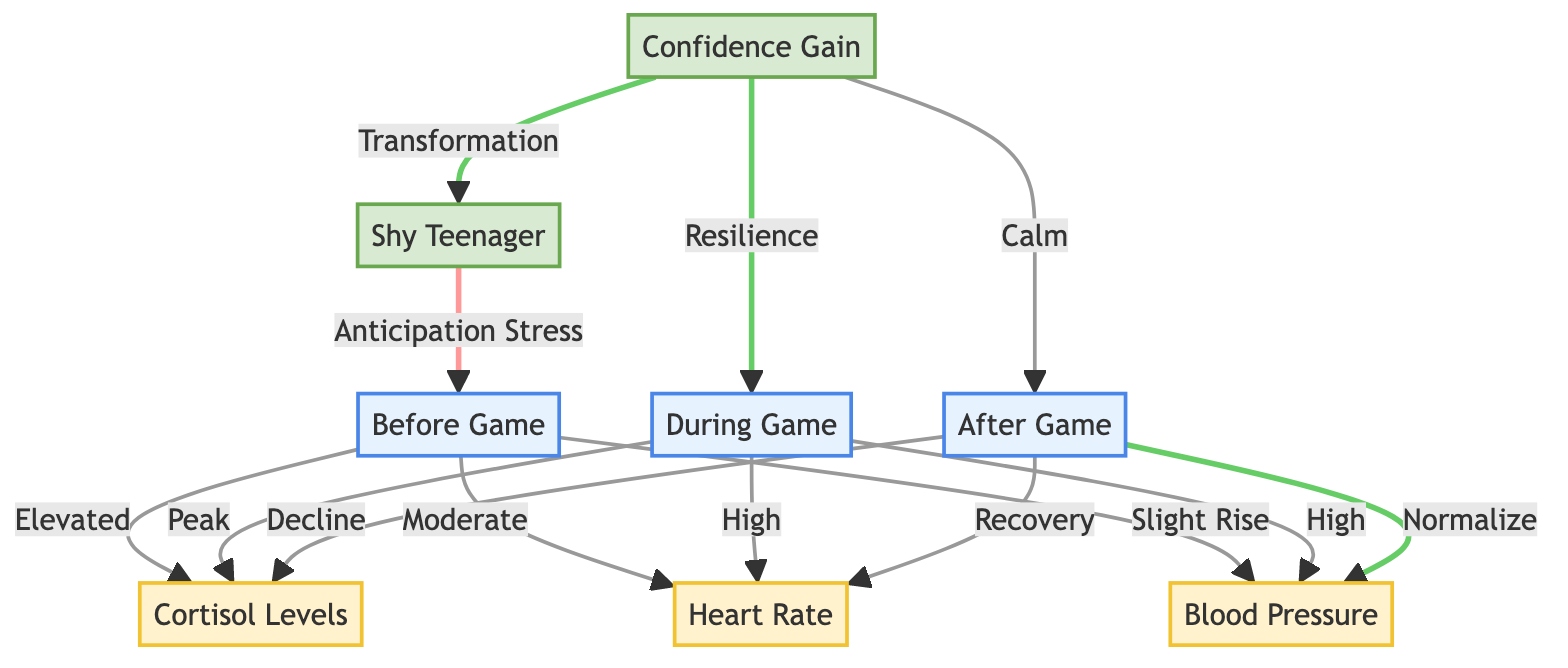What happens to cortisol levels before the game? The diagram indicates that cortisol levels are elevated before the game, showing a direct link between the state of anticipation stress and the physiological response of cortisol levels.
Answer: Elevated What is the heart rate status during the game? According to the diagram, the heart rate peaks during the game as indicated by the connection between the state of high pressure during the game and heart rate.
Answer: Peak How does blood pressure change after the game? The diagram illustrates a normalization of blood pressure after the game, as shown by the link between the after game state and the blood pressure response.
Answer: Normalize What physiological change is linked with gaining confidence? The diagram shows a transformation linked to confidence gain, which indicates that gaining confidence contributes significantly to the individual's physiological state.
Answer: Transformation How many states occur before, during, and after the game? The diagram indicates a total of three main states: before, during, and after the game, which simplifies the understanding of the sequence of physiological changes.
Answer: 3 What is the relationship between anticipation stress and cortisol levels? The diagram indicates that anticipation stress leads to elevated cortisol levels, establishing a direct causative relationship between stress and this hormonal response.
Answer: Elevated What occurs to heart rate after the game? Following the game, the diagram states that heart rate is in recovery, showing improvement after the peak levels encountered during the game.
Answer: Recovery 